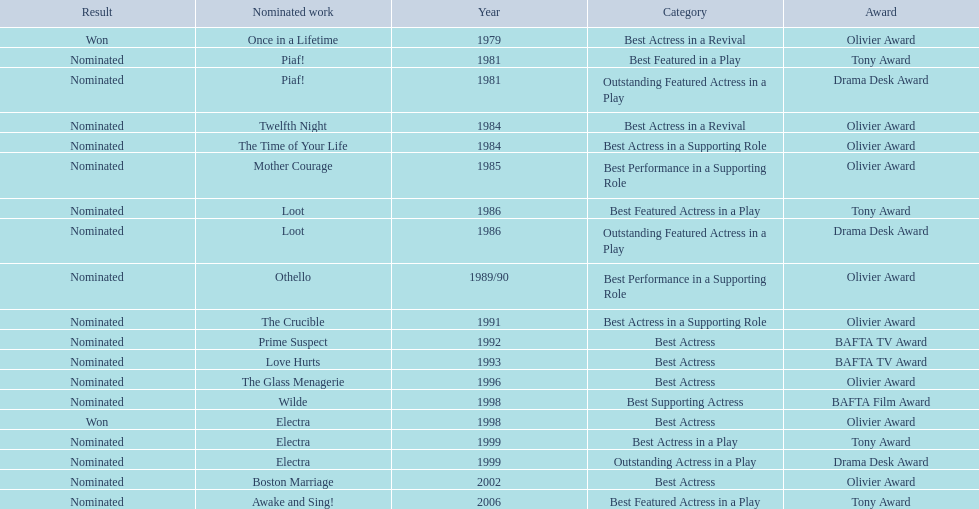Which works were nominated for the oliver award? Twelfth Night, The Time of Your Life, Mother Courage, Othello, The Crucible, The Glass Menagerie, Electra, Boston Marriage. Of these which ones did not win? Twelfth Night, The Time of Your Life, Mother Courage, Othello, The Crucible, The Glass Menagerie, Boston Marriage. Which of those were nominated for best actress of any kind in the 1080s? Twelfth Night, The Time of Your Life. Which of these was a revival? Twelfth Night. 